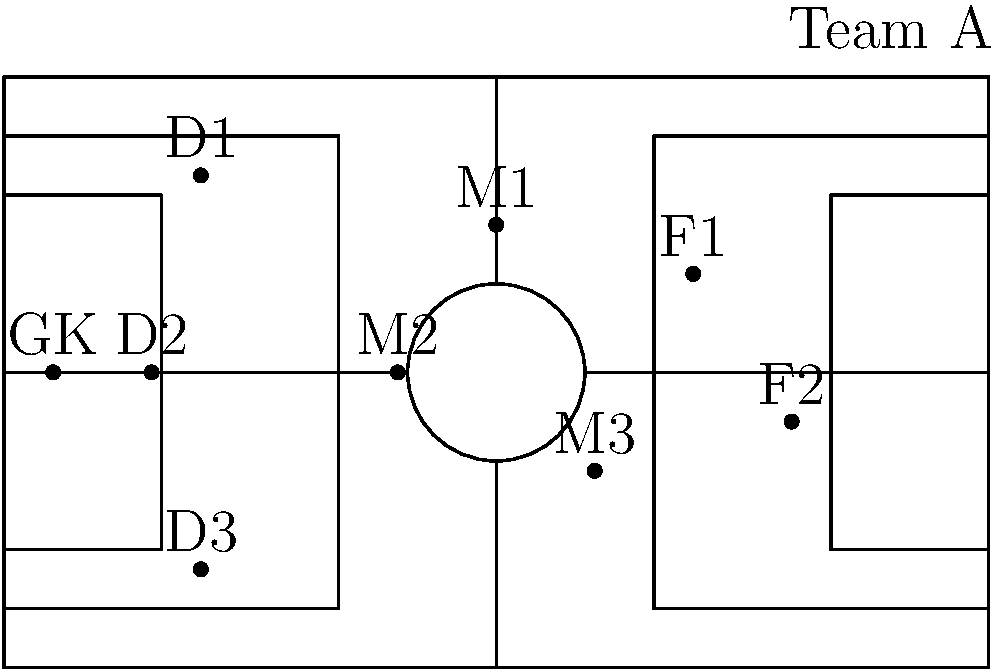In the given soccer field diagram, which formation is Team A likely employing, and how does this positioning strategy compare to the 4-4-2 formation we used when playing alongside Baldi Rossi? Discuss the potential advantages and disadvantages of this formation in terms of offensive and defensive capabilities. To answer this question, let's analyze the diagram and compare it to our experience with the 4-4-2 formation:

1. Identify the formation in the diagram:
   - 1 Goalkeeper (GK)
   - 3 Defenders (D1, D2, D3)
   - 3 Midfielders (M1, M2, M3)
   - 2 Forwards (F1, F2)

This appears to be a 3-3-2 formation.

2. Compare to 4-4-2 formation:
   - 4-4-2: 4 defenders, 4 midfielders, 2 forwards
   - 3-3-2: 3 defenders, 3 midfielders, 2 forwards

3. Analyze the positioning:
   - The 3-3-2 has one less defender and one less midfielder compared to 4-4-2
   - Defenders (D1, D2, D3) are spread across the back
   - Midfielders (M1, M2, M3) form a triangle in the center
   - Forwards (F1, F2) are positioned high up the field

4. Advantages of 3-3-2:
   - More attacking-oriented than 4-4-2
   - Allows for quick transitions from defense to attack
   - Creates numerical superiority in midfield when a defender pushes forward

5. Disadvantages of 3-3-2:
   - More vulnerable defensively, especially on counter-attacks
   - Requires high fitness levels and positional awareness from players
   - Less width in midfield compared to 4-4-2

6. Comparison to playing with Baldi Rossi in 4-4-2:
   - 4-4-2 offered more defensive stability
   - 3-3-2 allows for more fluid attacking movements
   - 4-4-2 provided better wide options in midfield
   - 3-3-2 might create more space for skilled players like Rossi to exploit

The 3-3-2 formation presents a more attack-minded approach compared to the 4-4-2 we used with Baldi Rossi, sacrificing some defensive stability for increased offensive potential.
Answer: 3-3-2 formation; more attack-oriented but less defensively stable than 4-4-2 